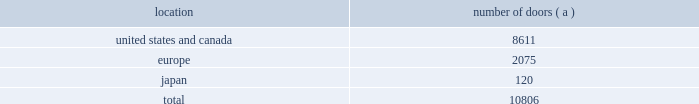Global brand concepts american living american living is the first brand developed under the newglobal brand concepts group .
American living is a full lifestyle brand , featuring menswear , womenswear , childrenswear , accessories and home furnishings with a focus on timeless , authentic american classics for every day .
American living is available exclusively at jcpenney in the u.s .
And online at jcp.com .
Our wholesale segment our wholesale segment sells our products to leading upscale and certain mid-tier department stores , specialty stores and golf and pro shops , both domestically and internationally .
We have focused on elevating our brand and improving productivity by reducing the number of unproductive doors within department stores in which our products are sold , improving in-store product assortment and presentation , and improving full-price sell-throughs to consumers .
As of march 29 , 2008 , the end of fiscal 2008 , our products were sold through 10806 doors worldwide , and during fiscal 2008 , we invested approximately $ 49 million in shop-within-shops dedicated to our products primarily in domestic and international department stores .
We have also effected selective price increases on basic products and introduced new fashion offerings at higher price points .
Department stores are our major wholesale customers in north america .
In europe , our wholesale sales are a varying mix of sales to both department stores and specialty shops , depending on the country .
Our collection brands 2014 women 2019s ralph lauren collection and black label and men 2019s purple label collection and black label 2014 are distributed through a limited number of premier fashion retailers .
In addition , we sell excess and out- of-season products through secondary distribution channels , including our retail factory stores .
In japan , our products are distributed primarily through shop-within-shops at premiere department stores .
The mix of business is weighted to polo ralph lauren inmen 2019s andwomen 2019s blue label .
The distribution of men 2019s and women 2019s black label is also expanding through shop-within-shop presentations in top tier department stores across japan .
Worldwide distribution channels the table presents the approximate number of doors by geographic location , in which products distributed by our wholesale segment were sold to consumers as of march 29 , 2008 : location number of doors ( a ) .
( a ) in asia/pacific ( excluding japan ) , our products are distributed by our licensing partners .
The following department store chains werewholesale customers whose purchases represented more than 10% ( 10 % ) of our worldwide wholesale net sales for the year ended march 29 , 2008 : 2022 macy 2019s , inc .
( formerly known as federated department stores , inc. ) , which represented approximately 24% ( 24 % ) ; and 2022 dillard department stores , inc. , which represented approximately 12% ( 12 % ) .
Our product brands are sold primarily through their own sales forces .
Our wholesale segment maintains their primary showrooms in new york city .
In addition , we maintain regional showrooms in atlanta , chicago , dallas , los angeles , milan , paris , london , munich , madrid and stockholm. .
What percentage of the wholesale segment as of march 29 , 2008 doors was in the europe geography? 
Computations: (2075 / 10806)
Answer: 0.19202. 